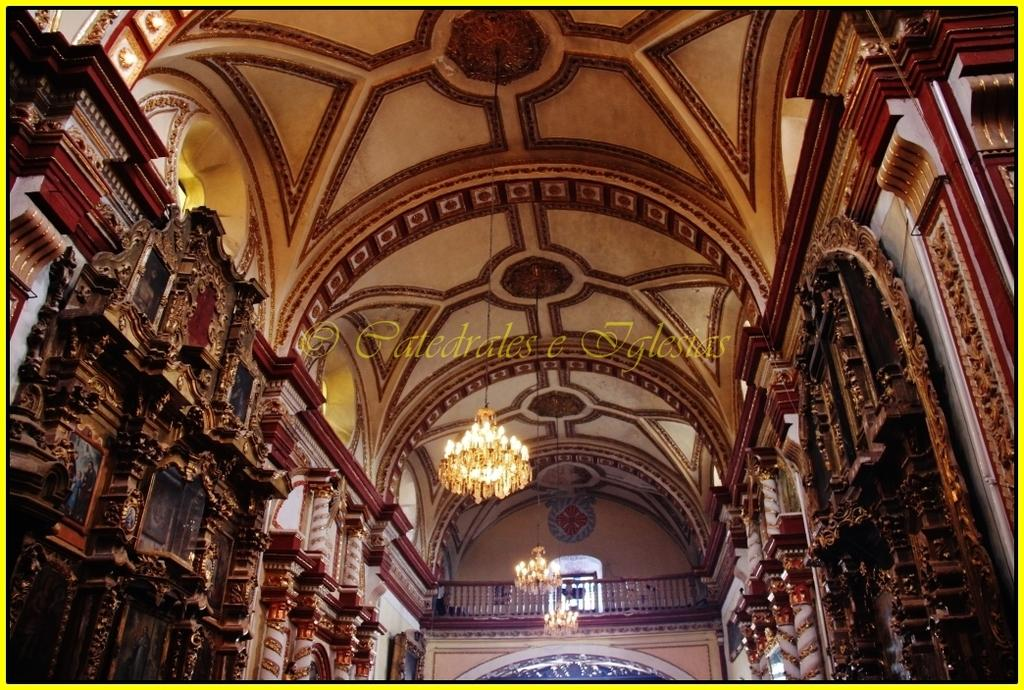What type of design can be seen on the walls in the image? There is a wooden design on the walls in the left and right corner. Can you describe the background of the image? There is a wall in the background, and there is also wooden railing visible. What can be seen hanging from the roof in the image? Lights are hanging on the roof at the top. What advice does the son give during the holiday in the image? There is no reference to a son or a holiday in the image, so it is not possible to answer that question. 